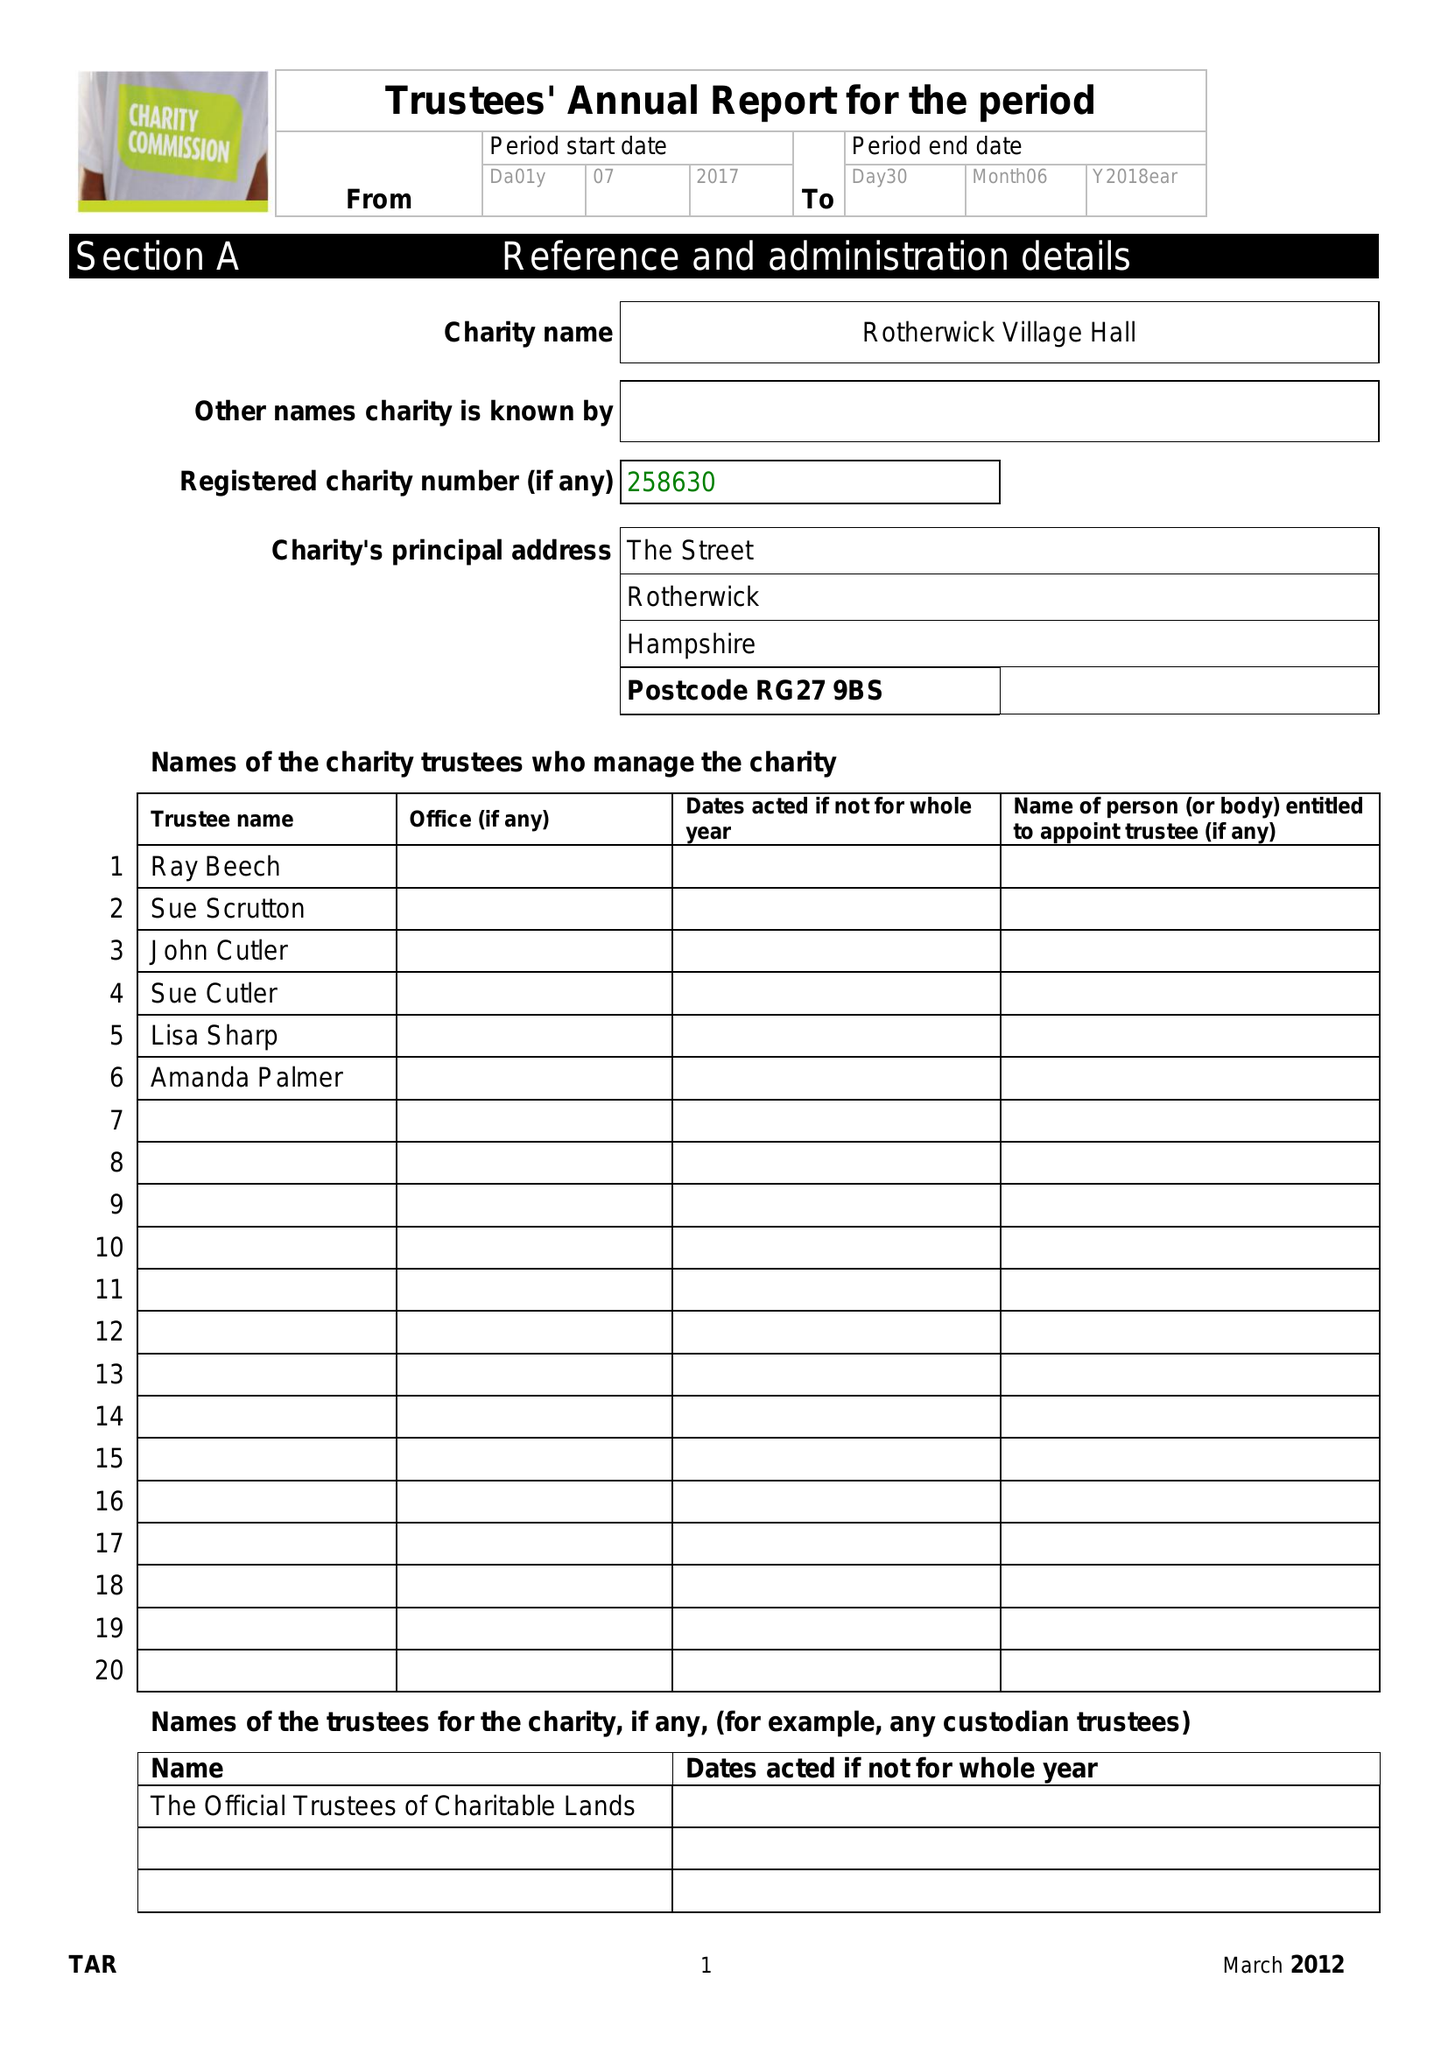What is the value for the address__postcode?
Answer the question using a single word or phrase. RG27 9BL 